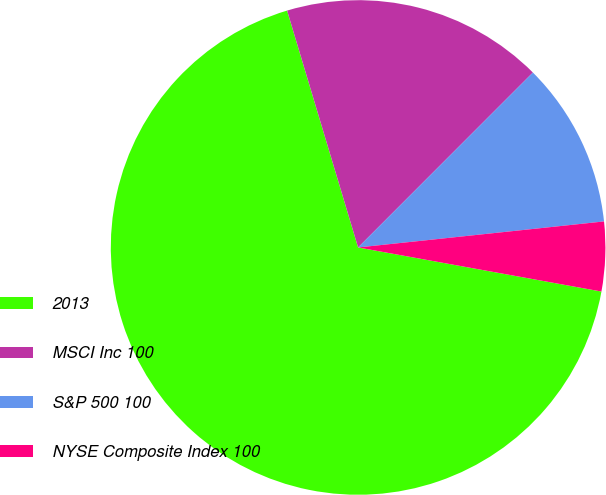Convert chart. <chart><loc_0><loc_0><loc_500><loc_500><pie_chart><fcel>2013<fcel>MSCI Inc 100<fcel>S&P 500 100<fcel>NYSE Composite Index 100<nl><fcel>67.52%<fcel>17.13%<fcel>10.83%<fcel>4.53%<nl></chart> 